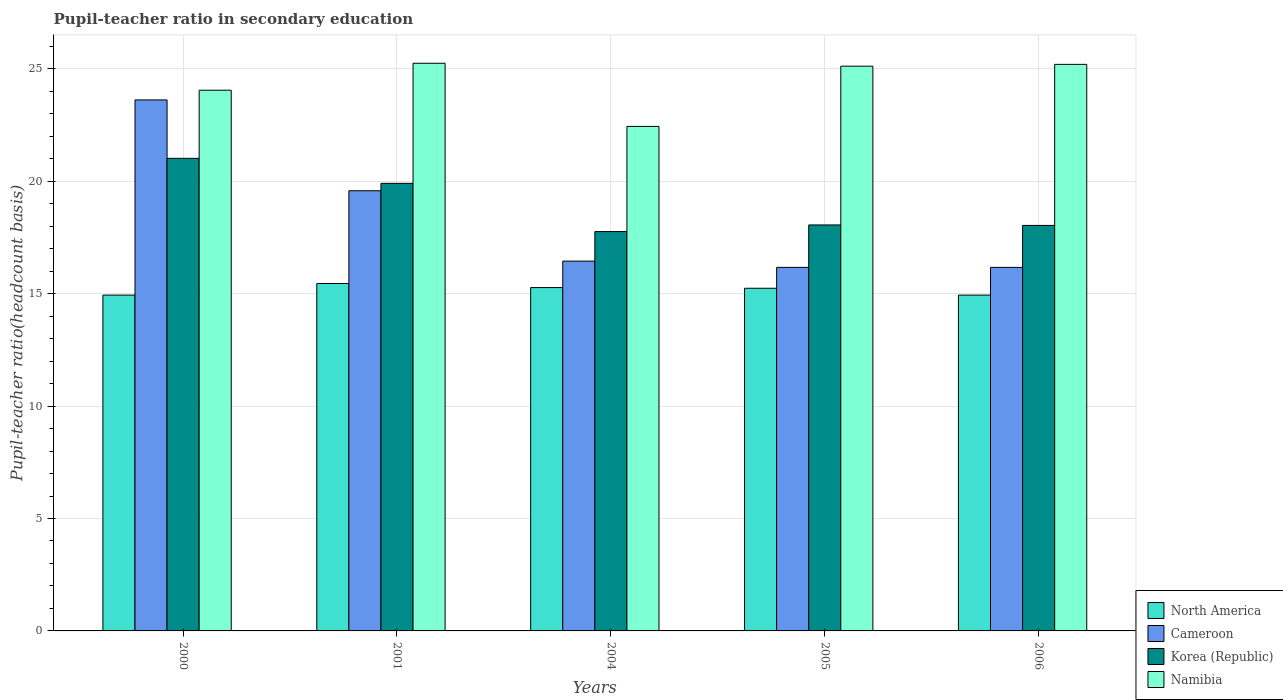How many different coloured bars are there?
Your response must be concise. 4. Are the number of bars on each tick of the X-axis equal?
Give a very brief answer. Yes. How many bars are there on the 2nd tick from the left?
Keep it short and to the point. 4. In how many cases, is the number of bars for a given year not equal to the number of legend labels?
Provide a succinct answer. 0. What is the pupil-teacher ratio in secondary education in North America in 2004?
Keep it short and to the point. 15.27. Across all years, what is the maximum pupil-teacher ratio in secondary education in Korea (Republic)?
Ensure brevity in your answer.  21.02. Across all years, what is the minimum pupil-teacher ratio in secondary education in North America?
Provide a succinct answer. 14.94. In which year was the pupil-teacher ratio in secondary education in Namibia maximum?
Keep it short and to the point. 2001. What is the total pupil-teacher ratio in secondary education in Cameroon in the graph?
Provide a succinct answer. 91.99. What is the difference between the pupil-teacher ratio in secondary education in Korea (Republic) in 2005 and that in 2006?
Keep it short and to the point. 0.02. What is the difference between the pupil-teacher ratio in secondary education in North America in 2005 and the pupil-teacher ratio in secondary education in Korea (Republic) in 2006?
Offer a terse response. -2.8. What is the average pupil-teacher ratio in secondary education in Cameroon per year?
Offer a very short reply. 18.4. In the year 2005, what is the difference between the pupil-teacher ratio in secondary education in Namibia and pupil-teacher ratio in secondary education in North America?
Your answer should be very brief. 9.88. In how many years, is the pupil-teacher ratio in secondary education in Namibia greater than 2?
Keep it short and to the point. 5. What is the ratio of the pupil-teacher ratio in secondary education in Korea (Republic) in 2001 to that in 2006?
Provide a short and direct response. 1.1. What is the difference between the highest and the second highest pupil-teacher ratio in secondary education in Korea (Republic)?
Provide a short and direct response. 1.11. What is the difference between the highest and the lowest pupil-teacher ratio in secondary education in Namibia?
Offer a very short reply. 2.81. Is the sum of the pupil-teacher ratio in secondary education in Cameroon in 2000 and 2005 greater than the maximum pupil-teacher ratio in secondary education in Namibia across all years?
Keep it short and to the point. Yes. What does the 4th bar from the right in 2001 represents?
Ensure brevity in your answer.  North America. How many years are there in the graph?
Offer a terse response. 5. What is the difference between two consecutive major ticks on the Y-axis?
Your answer should be compact. 5. Does the graph contain any zero values?
Make the answer very short. No. Where does the legend appear in the graph?
Your answer should be compact. Bottom right. How are the legend labels stacked?
Provide a succinct answer. Vertical. What is the title of the graph?
Your answer should be very brief. Pupil-teacher ratio in secondary education. Does "Tunisia" appear as one of the legend labels in the graph?
Provide a short and direct response. No. What is the label or title of the Y-axis?
Ensure brevity in your answer.  Pupil-teacher ratio(headcount basis). What is the Pupil-teacher ratio(headcount basis) of North America in 2000?
Keep it short and to the point. 14.94. What is the Pupil-teacher ratio(headcount basis) of Cameroon in 2000?
Ensure brevity in your answer.  23.62. What is the Pupil-teacher ratio(headcount basis) of Korea (Republic) in 2000?
Give a very brief answer. 21.02. What is the Pupil-teacher ratio(headcount basis) in Namibia in 2000?
Offer a terse response. 24.05. What is the Pupil-teacher ratio(headcount basis) in North America in 2001?
Keep it short and to the point. 15.45. What is the Pupil-teacher ratio(headcount basis) of Cameroon in 2001?
Your answer should be compact. 19.58. What is the Pupil-teacher ratio(headcount basis) of Korea (Republic) in 2001?
Provide a succinct answer. 19.91. What is the Pupil-teacher ratio(headcount basis) of Namibia in 2001?
Give a very brief answer. 25.25. What is the Pupil-teacher ratio(headcount basis) in North America in 2004?
Provide a succinct answer. 15.27. What is the Pupil-teacher ratio(headcount basis) of Cameroon in 2004?
Keep it short and to the point. 16.45. What is the Pupil-teacher ratio(headcount basis) of Korea (Republic) in 2004?
Offer a very short reply. 17.76. What is the Pupil-teacher ratio(headcount basis) of Namibia in 2004?
Your response must be concise. 22.44. What is the Pupil-teacher ratio(headcount basis) in North America in 2005?
Your response must be concise. 15.24. What is the Pupil-teacher ratio(headcount basis) of Cameroon in 2005?
Make the answer very short. 16.17. What is the Pupil-teacher ratio(headcount basis) of Korea (Republic) in 2005?
Ensure brevity in your answer.  18.06. What is the Pupil-teacher ratio(headcount basis) of Namibia in 2005?
Provide a succinct answer. 25.12. What is the Pupil-teacher ratio(headcount basis) of North America in 2006?
Offer a very short reply. 14.94. What is the Pupil-teacher ratio(headcount basis) of Cameroon in 2006?
Provide a succinct answer. 16.17. What is the Pupil-teacher ratio(headcount basis) in Korea (Republic) in 2006?
Provide a short and direct response. 18.04. What is the Pupil-teacher ratio(headcount basis) in Namibia in 2006?
Provide a succinct answer. 25.2. Across all years, what is the maximum Pupil-teacher ratio(headcount basis) in North America?
Offer a very short reply. 15.45. Across all years, what is the maximum Pupil-teacher ratio(headcount basis) in Cameroon?
Give a very brief answer. 23.62. Across all years, what is the maximum Pupil-teacher ratio(headcount basis) of Korea (Republic)?
Provide a succinct answer. 21.02. Across all years, what is the maximum Pupil-teacher ratio(headcount basis) in Namibia?
Your answer should be very brief. 25.25. Across all years, what is the minimum Pupil-teacher ratio(headcount basis) of North America?
Make the answer very short. 14.94. Across all years, what is the minimum Pupil-teacher ratio(headcount basis) of Cameroon?
Give a very brief answer. 16.17. Across all years, what is the minimum Pupil-teacher ratio(headcount basis) of Korea (Republic)?
Provide a short and direct response. 17.76. Across all years, what is the minimum Pupil-teacher ratio(headcount basis) in Namibia?
Provide a succinct answer. 22.44. What is the total Pupil-teacher ratio(headcount basis) in North America in the graph?
Keep it short and to the point. 75.84. What is the total Pupil-teacher ratio(headcount basis) of Cameroon in the graph?
Keep it short and to the point. 91.99. What is the total Pupil-teacher ratio(headcount basis) of Korea (Republic) in the graph?
Offer a very short reply. 94.79. What is the total Pupil-teacher ratio(headcount basis) of Namibia in the graph?
Ensure brevity in your answer.  122.06. What is the difference between the Pupil-teacher ratio(headcount basis) of North America in 2000 and that in 2001?
Provide a succinct answer. -0.52. What is the difference between the Pupil-teacher ratio(headcount basis) of Cameroon in 2000 and that in 2001?
Your answer should be very brief. 4.04. What is the difference between the Pupil-teacher ratio(headcount basis) in Korea (Republic) in 2000 and that in 2001?
Make the answer very short. 1.11. What is the difference between the Pupil-teacher ratio(headcount basis) of Namibia in 2000 and that in 2001?
Provide a short and direct response. -1.2. What is the difference between the Pupil-teacher ratio(headcount basis) of North America in 2000 and that in 2004?
Your answer should be very brief. -0.33. What is the difference between the Pupil-teacher ratio(headcount basis) of Cameroon in 2000 and that in 2004?
Provide a short and direct response. 7.17. What is the difference between the Pupil-teacher ratio(headcount basis) of Korea (Republic) in 2000 and that in 2004?
Make the answer very short. 3.26. What is the difference between the Pupil-teacher ratio(headcount basis) of Namibia in 2000 and that in 2004?
Keep it short and to the point. 1.61. What is the difference between the Pupil-teacher ratio(headcount basis) in North America in 2000 and that in 2005?
Make the answer very short. -0.3. What is the difference between the Pupil-teacher ratio(headcount basis) in Cameroon in 2000 and that in 2005?
Provide a short and direct response. 7.45. What is the difference between the Pupil-teacher ratio(headcount basis) of Korea (Republic) in 2000 and that in 2005?
Your answer should be very brief. 2.96. What is the difference between the Pupil-teacher ratio(headcount basis) of Namibia in 2000 and that in 2005?
Your answer should be very brief. -1.07. What is the difference between the Pupil-teacher ratio(headcount basis) in Cameroon in 2000 and that in 2006?
Make the answer very short. 7.45. What is the difference between the Pupil-teacher ratio(headcount basis) of Korea (Republic) in 2000 and that in 2006?
Offer a terse response. 2.98. What is the difference between the Pupil-teacher ratio(headcount basis) of Namibia in 2000 and that in 2006?
Make the answer very short. -1.15. What is the difference between the Pupil-teacher ratio(headcount basis) in North America in 2001 and that in 2004?
Keep it short and to the point. 0.18. What is the difference between the Pupil-teacher ratio(headcount basis) in Cameroon in 2001 and that in 2004?
Make the answer very short. 3.13. What is the difference between the Pupil-teacher ratio(headcount basis) of Korea (Republic) in 2001 and that in 2004?
Give a very brief answer. 2.15. What is the difference between the Pupil-teacher ratio(headcount basis) in Namibia in 2001 and that in 2004?
Provide a short and direct response. 2.81. What is the difference between the Pupil-teacher ratio(headcount basis) of North America in 2001 and that in 2005?
Provide a succinct answer. 0.21. What is the difference between the Pupil-teacher ratio(headcount basis) of Cameroon in 2001 and that in 2005?
Offer a very short reply. 3.41. What is the difference between the Pupil-teacher ratio(headcount basis) in Korea (Republic) in 2001 and that in 2005?
Ensure brevity in your answer.  1.85. What is the difference between the Pupil-teacher ratio(headcount basis) of Namibia in 2001 and that in 2005?
Give a very brief answer. 0.13. What is the difference between the Pupil-teacher ratio(headcount basis) in North America in 2001 and that in 2006?
Offer a very short reply. 0.52. What is the difference between the Pupil-teacher ratio(headcount basis) of Cameroon in 2001 and that in 2006?
Ensure brevity in your answer.  3.41. What is the difference between the Pupil-teacher ratio(headcount basis) of Korea (Republic) in 2001 and that in 2006?
Give a very brief answer. 1.87. What is the difference between the Pupil-teacher ratio(headcount basis) of Namibia in 2001 and that in 2006?
Keep it short and to the point. 0.05. What is the difference between the Pupil-teacher ratio(headcount basis) in North America in 2004 and that in 2005?
Make the answer very short. 0.03. What is the difference between the Pupil-teacher ratio(headcount basis) in Cameroon in 2004 and that in 2005?
Your response must be concise. 0.28. What is the difference between the Pupil-teacher ratio(headcount basis) in Korea (Republic) in 2004 and that in 2005?
Ensure brevity in your answer.  -0.29. What is the difference between the Pupil-teacher ratio(headcount basis) in Namibia in 2004 and that in 2005?
Keep it short and to the point. -2.68. What is the difference between the Pupil-teacher ratio(headcount basis) in North America in 2004 and that in 2006?
Give a very brief answer. 0.34. What is the difference between the Pupil-teacher ratio(headcount basis) in Cameroon in 2004 and that in 2006?
Provide a succinct answer. 0.28. What is the difference between the Pupil-teacher ratio(headcount basis) in Korea (Republic) in 2004 and that in 2006?
Your answer should be very brief. -0.27. What is the difference between the Pupil-teacher ratio(headcount basis) of Namibia in 2004 and that in 2006?
Your response must be concise. -2.76. What is the difference between the Pupil-teacher ratio(headcount basis) of North America in 2005 and that in 2006?
Ensure brevity in your answer.  0.31. What is the difference between the Pupil-teacher ratio(headcount basis) of Cameroon in 2005 and that in 2006?
Your answer should be very brief. -0. What is the difference between the Pupil-teacher ratio(headcount basis) in Korea (Republic) in 2005 and that in 2006?
Make the answer very short. 0.02. What is the difference between the Pupil-teacher ratio(headcount basis) in Namibia in 2005 and that in 2006?
Keep it short and to the point. -0.08. What is the difference between the Pupil-teacher ratio(headcount basis) in North America in 2000 and the Pupil-teacher ratio(headcount basis) in Cameroon in 2001?
Your answer should be compact. -4.64. What is the difference between the Pupil-teacher ratio(headcount basis) in North America in 2000 and the Pupil-teacher ratio(headcount basis) in Korea (Republic) in 2001?
Keep it short and to the point. -4.97. What is the difference between the Pupil-teacher ratio(headcount basis) in North America in 2000 and the Pupil-teacher ratio(headcount basis) in Namibia in 2001?
Keep it short and to the point. -10.31. What is the difference between the Pupil-teacher ratio(headcount basis) of Cameroon in 2000 and the Pupil-teacher ratio(headcount basis) of Korea (Republic) in 2001?
Your answer should be compact. 3.71. What is the difference between the Pupil-teacher ratio(headcount basis) of Cameroon in 2000 and the Pupil-teacher ratio(headcount basis) of Namibia in 2001?
Ensure brevity in your answer.  -1.63. What is the difference between the Pupil-teacher ratio(headcount basis) of Korea (Republic) in 2000 and the Pupil-teacher ratio(headcount basis) of Namibia in 2001?
Make the answer very short. -4.23. What is the difference between the Pupil-teacher ratio(headcount basis) of North America in 2000 and the Pupil-teacher ratio(headcount basis) of Cameroon in 2004?
Keep it short and to the point. -1.51. What is the difference between the Pupil-teacher ratio(headcount basis) of North America in 2000 and the Pupil-teacher ratio(headcount basis) of Korea (Republic) in 2004?
Your answer should be compact. -2.83. What is the difference between the Pupil-teacher ratio(headcount basis) in North America in 2000 and the Pupil-teacher ratio(headcount basis) in Namibia in 2004?
Offer a very short reply. -7.5. What is the difference between the Pupil-teacher ratio(headcount basis) in Cameroon in 2000 and the Pupil-teacher ratio(headcount basis) in Korea (Republic) in 2004?
Offer a very short reply. 5.86. What is the difference between the Pupil-teacher ratio(headcount basis) in Cameroon in 2000 and the Pupil-teacher ratio(headcount basis) in Namibia in 2004?
Give a very brief answer. 1.18. What is the difference between the Pupil-teacher ratio(headcount basis) in Korea (Republic) in 2000 and the Pupil-teacher ratio(headcount basis) in Namibia in 2004?
Provide a short and direct response. -1.42. What is the difference between the Pupil-teacher ratio(headcount basis) in North America in 2000 and the Pupil-teacher ratio(headcount basis) in Cameroon in 2005?
Keep it short and to the point. -1.23. What is the difference between the Pupil-teacher ratio(headcount basis) in North America in 2000 and the Pupil-teacher ratio(headcount basis) in Korea (Republic) in 2005?
Make the answer very short. -3.12. What is the difference between the Pupil-teacher ratio(headcount basis) of North America in 2000 and the Pupil-teacher ratio(headcount basis) of Namibia in 2005?
Your response must be concise. -10.18. What is the difference between the Pupil-teacher ratio(headcount basis) in Cameroon in 2000 and the Pupil-teacher ratio(headcount basis) in Korea (Republic) in 2005?
Make the answer very short. 5.56. What is the difference between the Pupil-teacher ratio(headcount basis) of Cameroon in 2000 and the Pupil-teacher ratio(headcount basis) of Namibia in 2005?
Provide a succinct answer. -1.5. What is the difference between the Pupil-teacher ratio(headcount basis) of Korea (Republic) in 2000 and the Pupil-teacher ratio(headcount basis) of Namibia in 2005?
Offer a very short reply. -4.1. What is the difference between the Pupil-teacher ratio(headcount basis) in North America in 2000 and the Pupil-teacher ratio(headcount basis) in Cameroon in 2006?
Give a very brief answer. -1.23. What is the difference between the Pupil-teacher ratio(headcount basis) of North America in 2000 and the Pupil-teacher ratio(headcount basis) of Korea (Republic) in 2006?
Your answer should be very brief. -3.1. What is the difference between the Pupil-teacher ratio(headcount basis) in North America in 2000 and the Pupil-teacher ratio(headcount basis) in Namibia in 2006?
Give a very brief answer. -10.26. What is the difference between the Pupil-teacher ratio(headcount basis) of Cameroon in 2000 and the Pupil-teacher ratio(headcount basis) of Korea (Republic) in 2006?
Provide a succinct answer. 5.58. What is the difference between the Pupil-teacher ratio(headcount basis) of Cameroon in 2000 and the Pupil-teacher ratio(headcount basis) of Namibia in 2006?
Provide a succinct answer. -1.58. What is the difference between the Pupil-teacher ratio(headcount basis) of Korea (Republic) in 2000 and the Pupil-teacher ratio(headcount basis) of Namibia in 2006?
Offer a very short reply. -4.18. What is the difference between the Pupil-teacher ratio(headcount basis) of North America in 2001 and the Pupil-teacher ratio(headcount basis) of Cameroon in 2004?
Provide a succinct answer. -0.99. What is the difference between the Pupil-teacher ratio(headcount basis) in North America in 2001 and the Pupil-teacher ratio(headcount basis) in Korea (Republic) in 2004?
Your answer should be compact. -2.31. What is the difference between the Pupil-teacher ratio(headcount basis) of North America in 2001 and the Pupil-teacher ratio(headcount basis) of Namibia in 2004?
Your answer should be compact. -6.99. What is the difference between the Pupil-teacher ratio(headcount basis) in Cameroon in 2001 and the Pupil-teacher ratio(headcount basis) in Korea (Republic) in 2004?
Give a very brief answer. 1.82. What is the difference between the Pupil-teacher ratio(headcount basis) in Cameroon in 2001 and the Pupil-teacher ratio(headcount basis) in Namibia in 2004?
Your answer should be compact. -2.86. What is the difference between the Pupil-teacher ratio(headcount basis) of Korea (Republic) in 2001 and the Pupil-teacher ratio(headcount basis) of Namibia in 2004?
Offer a very short reply. -2.53. What is the difference between the Pupil-teacher ratio(headcount basis) in North America in 2001 and the Pupil-teacher ratio(headcount basis) in Cameroon in 2005?
Your answer should be compact. -0.72. What is the difference between the Pupil-teacher ratio(headcount basis) of North America in 2001 and the Pupil-teacher ratio(headcount basis) of Korea (Republic) in 2005?
Give a very brief answer. -2.6. What is the difference between the Pupil-teacher ratio(headcount basis) of North America in 2001 and the Pupil-teacher ratio(headcount basis) of Namibia in 2005?
Make the answer very short. -9.66. What is the difference between the Pupil-teacher ratio(headcount basis) in Cameroon in 2001 and the Pupil-teacher ratio(headcount basis) in Korea (Republic) in 2005?
Give a very brief answer. 1.52. What is the difference between the Pupil-teacher ratio(headcount basis) in Cameroon in 2001 and the Pupil-teacher ratio(headcount basis) in Namibia in 2005?
Offer a terse response. -5.54. What is the difference between the Pupil-teacher ratio(headcount basis) in Korea (Republic) in 2001 and the Pupil-teacher ratio(headcount basis) in Namibia in 2005?
Offer a terse response. -5.21. What is the difference between the Pupil-teacher ratio(headcount basis) in North America in 2001 and the Pupil-teacher ratio(headcount basis) in Cameroon in 2006?
Make the answer very short. -0.72. What is the difference between the Pupil-teacher ratio(headcount basis) of North America in 2001 and the Pupil-teacher ratio(headcount basis) of Korea (Republic) in 2006?
Offer a very short reply. -2.58. What is the difference between the Pupil-teacher ratio(headcount basis) in North America in 2001 and the Pupil-teacher ratio(headcount basis) in Namibia in 2006?
Offer a terse response. -9.75. What is the difference between the Pupil-teacher ratio(headcount basis) in Cameroon in 2001 and the Pupil-teacher ratio(headcount basis) in Korea (Republic) in 2006?
Your response must be concise. 1.54. What is the difference between the Pupil-teacher ratio(headcount basis) in Cameroon in 2001 and the Pupil-teacher ratio(headcount basis) in Namibia in 2006?
Your answer should be very brief. -5.62. What is the difference between the Pupil-teacher ratio(headcount basis) in Korea (Republic) in 2001 and the Pupil-teacher ratio(headcount basis) in Namibia in 2006?
Give a very brief answer. -5.29. What is the difference between the Pupil-teacher ratio(headcount basis) in North America in 2004 and the Pupil-teacher ratio(headcount basis) in Cameroon in 2005?
Ensure brevity in your answer.  -0.9. What is the difference between the Pupil-teacher ratio(headcount basis) in North America in 2004 and the Pupil-teacher ratio(headcount basis) in Korea (Republic) in 2005?
Ensure brevity in your answer.  -2.79. What is the difference between the Pupil-teacher ratio(headcount basis) in North America in 2004 and the Pupil-teacher ratio(headcount basis) in Namibia in 2005?
Your response must be concise. -9.85. What is the difference between the Pupil-teacher ratio(headcount basis) in Cameroon in 2004 and the Pupil-teacher ratio(headcount basis) in Korea (Republic) in 2005?
Offer a terse response. -1.61. What is the difference between the Pupil-teacher ratio(headcount basis) in Cameroon in 2004 and the Pupil-teacher ratio(headcount basis) in Namibia in 2005?
Provide a short and direct response. -8.67. What is the difference between the Pupil-teacher ratio(headcount basis) in Korea (Republic) in 2004 and the Pupil-teacher ratio(headcount basis) in Namibia in 2005?
Your response must be concise. -7.36. What is the difference between the Pupil-teacher ratio(headcount basis) in North America in 2004 and the Pupil-teacher ratio(headcount basis) in Cameroon in 2006?
Provide a short and direct response. -0.9. What is the difference between the Pupil-teacher ratio(headcount basis) in North America in 2004 and the Pupil-teacher ratio(headcount basis) in Korea (Republic) in 2006?
Give a very brief answer. -2.77. What is the difference between the Pupil-teacher ratio(headcount basis) in North America in 2004 and the Pupil-teacher ratio(headcount basis) in Namibia in 2006?
Ensure brevity in your answer.  -9.93. What is the difference between the Pupil-teacher ratio(headcount basis) of Cameroon in 2004 and the Pupil-teacher ratio(headcount basis) of Korea (Republic) in 2006?
Provide a succinct answer. -1.59. What is the difference between the Pupil-teacher ratio(headcount basis) of Cameroon in 2004 and the Pupil-teacher ratio(headcount basis) of Namibia in 2006?
Make the answer very short. -8.75. What is the difference between the Pupil-teacher ratio(headcount basis) in Korea (Republic) in 2004 and the Pupil-teacher ratio(headcount basis) in Namibia in 2006?
Your answer should be compact. -7.44. What is the difference between the Pupil-teacher ratio(headcount basis) in North America in 2005 and the Pupil-teacher ratio(headcount basis) in Cameroon in 2006?
Your answer should be compact. -0.93. What is the difference between the Pupil-teacher ratio(headcount basis) in North America in 2005 and the Pupil-teacher ratio(headcount basis) in Korea (Republic) in 2006?
Ensure brevity in your answer.  -2.8. What is the difference between the Pupil-teacher ratio(headcount basis) of North America in 2005 and the Pupil-teacher ratio(headcount basis) of Namibia in 2006?
Keep it short and to the point. -9.96. What is the difference between the Pupil-teacher ratio(headcount basis) in Cameroon in 2005 and the Pupil-teacher ratio(headcount basis) in Korea (Republic) in 2006?
Your answer should be very brief. -1.87. What is the difference between the Pupil-teacher ratio(headcount basis) of Cameroon in 2005 and the Pupil-teacher ratio(headcount basis) of Namibia in 2006?
Provide a short and direct response. -9.03. What is the difference between the Pupil-teacher ratio(headcount basis) of Korea (Republic) in 2005 and the Pupil-teacher ratio(headcount basis) of Namibia in 2006?
Your answer should be compact. -7.14. What is the average Pupil-teacher ratio(headcount basis) of North America per year?
Your answer should be very brief. 15.17. What is the average Pupil-teacher ratio(headcount basis) of Cameroon per year?
Your answer should be very brief. 18.4. What is the average Pupil-teacher ratio(headcount basis) of Korea (Republic) per year?
Your response must be concise. 18.96. What is the average Pupil-teacher ratio(headcount basis) of Namibia per year?
Offer a very short reply. 24.41. In the year 2000, what is the difference between the Pupil-teacher ratio(headcount basis) of North America and Pupil-teacher ratio(headcount basis) of Cameroon?
Keep it short and to the point. -8.68. In the year 2000, what is the difference between the Pupil-teacher ratio(headcount basis) of North America and Pupil-teacher ratio(headcount basis) of Korea (Republic)?
Your answer should be compact. -6.08. In the year 2000, what is the difference between the Pupil-teacher ratio(headcount basis) of North America and Pupil-teacher ratio(headcount basis) of Namibia?
Give a very brief answer. -9.11. In the year 2000, what is the difference between the Pupil-teacher ratio(headcount basis) of Cameroon and Pupil-teacher ratio(headcount basis) of Korea (Republic)?
Keep it short and to the point. 2.6. In the year 2000, what is the difference between the Pupil-teacher ratio(headcount basis) of Cameroon and Pupil-teacher ratio(headcount basis) of Namibia?
Your answer should be very brief. -0.43. In the year 2000, what is the difference between the Pupil-teacher ratio(headcount basis) in Korea (Republic) and Pupil-teacher ratio(headcount basis) in Namibia?
Provide a short and direct response. -3.03. In the year 2001, what is the difference between the Pupil-teacher ratio(headcount basis) of North America and Pupil-teacher ratio(headcount basis) of Cameroon?
Your answer should be compact. -4.12. In the year 2001, what is the difference between the Pupil-teacher ratio(headcount basis) in North America and Pupil-teacher ratio(headcount basis) in Korea (Republic)?
Offer a very short reply. -4.45. In the year 2001, what is the difference between the Pupil-teacher ratio(headcount basis) of North America and Pupil-teacher ratio(headcount basis) of Namibia?
Keep it short and to the point. -9.79. In the year 2001, what is the difference between the Pupil-teacher ratio(headcount basis) of Cameroon and Pupil-teacher ratio(headcount basis) of Korea (Republic)?
Offer a very short reply. -0.33. In the year 2001, what is the difference between the Pupil-teacher ratio(headcount basis) of Cameroon and Pupil-teacher ratio(headcount basis) of Namibia?
Give a very brief answer. -5.67. In the year 2001, what is the difference between the Pupil-teacher ratio(headcount basis) of Korea (Republic) and Pupil-teacher ratio(headcount basis) of Namibia?
Offer a terse response. -5.34. In the year 2004, what is the difference between the Pupil-teacher ratio(headcount basis) in North America and Pupil-teacher ratio(headcount basis) in Cameroon?
Make the answer very short. -1.18. In the year 2004, what is the difference between the Pupil-teacher ratio(headcount basis) of North America and Pupil-teacher ratio(headcount basis) of Korea (Republic)?
Offer a very short reply. -2.49. In the year 2004, what is the difference between the Pupil-teacher ratio(headcount basis) in North America and Pupil-teacher ratio(headcount basis) in Namibia?
Your answer should be very brief. -7.17. In the year 2004, what is the difference between the Pupil-teacher ratio(headcount basis) in Cameroon and Pupil-teacher ratio(headcount basis) in Korea (Republic)?
Your response must be concise. -1.31. In the year 2004, what is the difference between the Pupil-teacher ratio(headcount basis) in Cameroon and Pupil-teacher ratio(headcount basis) in Namibia?
Ensure brevity in your answer.  -5.99. In the year 2004, what is the difference between the Pupil-teacher ratio(headcount basis) in Korea (Republic) and Pupil-teacher ratio(headcount basis) in Namibia?
Offer a terse response. -4.68. In the year 2005, what is the difference between the Pupil-teacher ratio(headcount basis) of North America and Pupil-teacher ratio(headcount basis) of Cameroon?
Keep it short and to the point. -0.93. In the year 2005, what is the difference between the Pupil-teacher ratio(headcount basis) in North America and Pupil-teacher ratio(headcount basis) in Korea (Republic)?
Offer a terse response. -2.82. In the year 2005, what is the difference between the Pupil-teacher ratio(headcount basis) in North America and Pupil-teacher ratio(headcount basis) in Namibia?
Your response must be concise. -9.88. In the year 2005, what is the difference between the Pupil-teacher ratio(headcount basis) of Cameroon and Pupil-teacher ratio(headcount basis) of Korea (Republic)?
Provide a succinct answer. -1.89. In the year 2005, what is the difference between the Pupil-teacher ratio(headcount basis) of Cameroon and Pupil-teacher ratio(headcount basis) of Namibia?
Your answer should be very brief. -8.95. In the year 2005, what is the difference between the Pupil-teacher ratio(headcount basis) of Korea (Republic) and Pupil-teacher ratio(headcount basis) of Namibia?
Ensure brevity in your answer.  -7.06. In the year 2006, what is the difference between the Pupil-teacher ratio(headcount basis) of North America and Pupil-teacher ratio(headcount basis) of Cameroon?
Keep it short and to the point. -1.23. In the year 2006, what is the difference between the Pupil-teacher ratio(headcount basis) in North America and Pupil-teacher ratio(headcount basis) in Korea (Republic)?
Offer a very short reply. -3.1. In the year 2006, what is the difference between the Pupil-teacher ratio(headcount basis) in North America and Pupil-teacher ratio(headcount basis) in Namibia?
Give a very brief answer. -10.26. In the year 2006, what is the difference between the Pupil-teacher ratio(headcount basis) of Cameroon and Pupil-teacher ratio(headcount basis) of Korea (Republic)?
Keep it short and to the point. -1.87. In the year 2006, what is the difference between the Pupil-teacher ratio(headcount basis) of Cameroon and Pupil-teacher ratio(headcount basis) of Namibia?
Provide a short and direct response. -9.03. In the year 2006, what is the difference between the Pupil-teacher ratio(headcount basis) in Korea (Republic) and Pupil-teacher ratio(headcount basis) in Namibia?
Your answer should be very brief. -7.16. What is the ratio of the Pupil-teacher ratio(headcount basis) of North America in 2000 to that in 2001?
Provide a short and direct response. 0.97. What is the ratio of the Pupil-teacher ratio(headcount basis) of Cameroon in 2000 to that in 2001?
Your response must be concise. 1.21. What is the ratio of the Pupil-teacher ratio(headcount basis) in Korea (Republic) in 2000 to that in 2001?
Ensure brevity in your answer.  1.06. What is the ratio of the Pupil-teacher ratio(headcount basis) of Namibia in 2000 to that in 2001?
Make the answer very short. 0.95. What is the ratio of the Pupil-teacher ratio(headcount basis) in North America in 2000 to that in 2004?
Offer a very short reply. 0.98. What is the ratio of the Pupil-teacher ratio(headcount basis) in Cameroon in 2000 to that in 2004?
Offer a terse response. 1.44. What is the ratio of the Pupil-teacher ratio(headcount basis) of Korea (Republic) in 2000 to that in 2004?
Ensure brevity in your answer.  1.18. What is the ratio of the Pupil-teacher ratio(headcount basis) in Namibia in 2000 to that in 2004?
Give a very brief answer. 1.07. What is the ratio of the Pupil-teacher ratio(headcount basis) of Cameroon in 2000 to that in 2005?
Keep it short and to the point. 1.46. What is the ratio of the Pupil-teacher ratio(headcount basis) in Korea (Republic) in 2000 to that in 2005?
Offer a terse response. 1.16. What is the ratio of the Pupil-teacher ratio(headcount basis) of Namibia in 2000 to that in 2005?
Provide a succinct answer. 0.96. What is the ratio of the Pupil-teacher ratio(headcount basis) in North America in 2000 to that in 2006?
Offer a terse response. 1. What is the ratio of the Pupil-teacher ratio(headcount basis) in Cameroon in 2000 to that in 2006?
Give a very brief answer. 1.46. What is the ratio of the Pupil-teacher ratio(headcount basis) in Korea (Republic) in 2000 to that in 2006?
Offer a terse response. 1.17. What is the ratio of the Pupil-teacher ratio(headcount basis) of Namibia in 2000 to that in 2006?
Your answer should be very brief. 0.95. What is the ratio of the Pupil-teacher ratio(headcount basis) of Cameroon in 2001 to that in 2004?
Keep it short and to the point. 1.19. What is the ratio of the Pupil-teacher ratio(headcount basis) of Korea (Republic) in 2001 to that in 2004?
Give a very brief answer. 1.12. What is the ratio of the Pupil-teacher ratio(headcount basis) in Namibia in 2001 to that in 2004?
Your response must be concise. 1.13. What is the ratio of the Pupil-teacher ratio(headcount basis) of North America in 2001 to that in 2005?
Offer a terse response. 1.01. What is the ratio of the Pupil-teacher ratio(headcount basis) of Cameroon in 2001 to that in 2005?
Provide a short and direct response. 1.21. What is the ratio of the Pupil-teacher ratio(headcount basis) of Korea (Republic) in 2001 to that in 2005?
Ensure brevity in your answer.  1.1. What is the ratio of the Pupil-teacher ratio(headcount basis) in Namibia in 2001 to that in 2005?
Your response must be concise. 1.01. What is the ratio of the Pupil-teacher ratio(headcount basis) in North America in 2001 to that in 2006?
Your response must be concise. 1.03. What is the ratio of the Pupil-teacher ratio(headcount basis) in Cameroon in 2001 to that in 2006?
Your answer should be very brief. 1.21. What is the ratio of the Pupil-teacher ratio(headcount basis) of Korea (Republic) in 2001 to that in 2006?
Ensure brevity in your answer.  1.1. What is the ratio of the Pupil-teacher ratio(headcount basis) of Namibia in 2001 to that in 2006?
Ensure brevity in your answer.  1. What is the ratio of the Pupil-teacher ratio(headcount basis) in Cameroon in 2004 to that in 2005?
Offer a terse response. 1.02. What is the ratio of the Pupil-teacher ratio(headcount basis) of Korea (Republic) in 2004 to that in 2005?
Give a very brief answer. 0.98. What is the ratio of the Pupil-teacher ratio(headcount basis) in Namibia in 2004 to that in 2005?
Keep it short and to the point. 0.89. What is the ratio of the Pupil-teacher ratio(headcount basis) of North America in 2004 to that in 2006?
Offer a very short reply. 1.02. What is the ratio of the Pupil-teacher ratio(headcount basis) in Cameroon in 2004 to that in 2006?
Make the answer very short. 1.02. What is the ratio of the Pupil-teacher ratio(headcount basis) of Korea (Republic) in 2004 to that in 2006?
Provide a succinct answer. 0.98. What is the ratio of the Pupil-teacher ratio(headcount basis) of Namibia in 2004 to that in 2006?
Your answer should be very brief. 0.89. What is the ratio of the Pupil-teacher ratio(headcount basis) of North America in 2005 to that in 2006?
Your answer should be compact. 1.02. What is the ratio of the Pupil-teacher ratio(headcount basis) in Namibia in 2005 to that in 2006?
Make the answer very short. 1. What is the difference between the highest and the second highest Pupil-teacher ratio(headcount basis) in North America?
Provide a succinct answer. 0.18. What is the difference between the highest and the second highest Pupil-teacher ratio(headcount basis) in Cameroon?
Your answer should be very brief. 4.04. What is the difference between the highest and the second highest Pupil-teacher ratio(headcount basis) in Korea (Republic)?
Provide a short and direct response. 1.11. What is the difference between the highest and the second highest Pupil-teacher ratio(headcount basis) of Namibia?
Give a very brief answer. 0.05. What is the difference between the highest and the lowest Pupil-teacher ratio(headcount basis) in North America?
Your answer should be very brief. 0.52. What is the difference between the highest and the lowest Pupil-teacher ratio(headcount basis) in Cameroon?
Offer a very short reply. 7.45. What is the difference between the highest and the lowest Pupil-teacher ratio(headcount basis) of Korea (Republic)?
Your response must be concise. 3.26. What is the difference between the highest and the lowest Pupil-teacher ratio(headcount basis) of Namibia?
Your answer should be very brief. 2.81. 